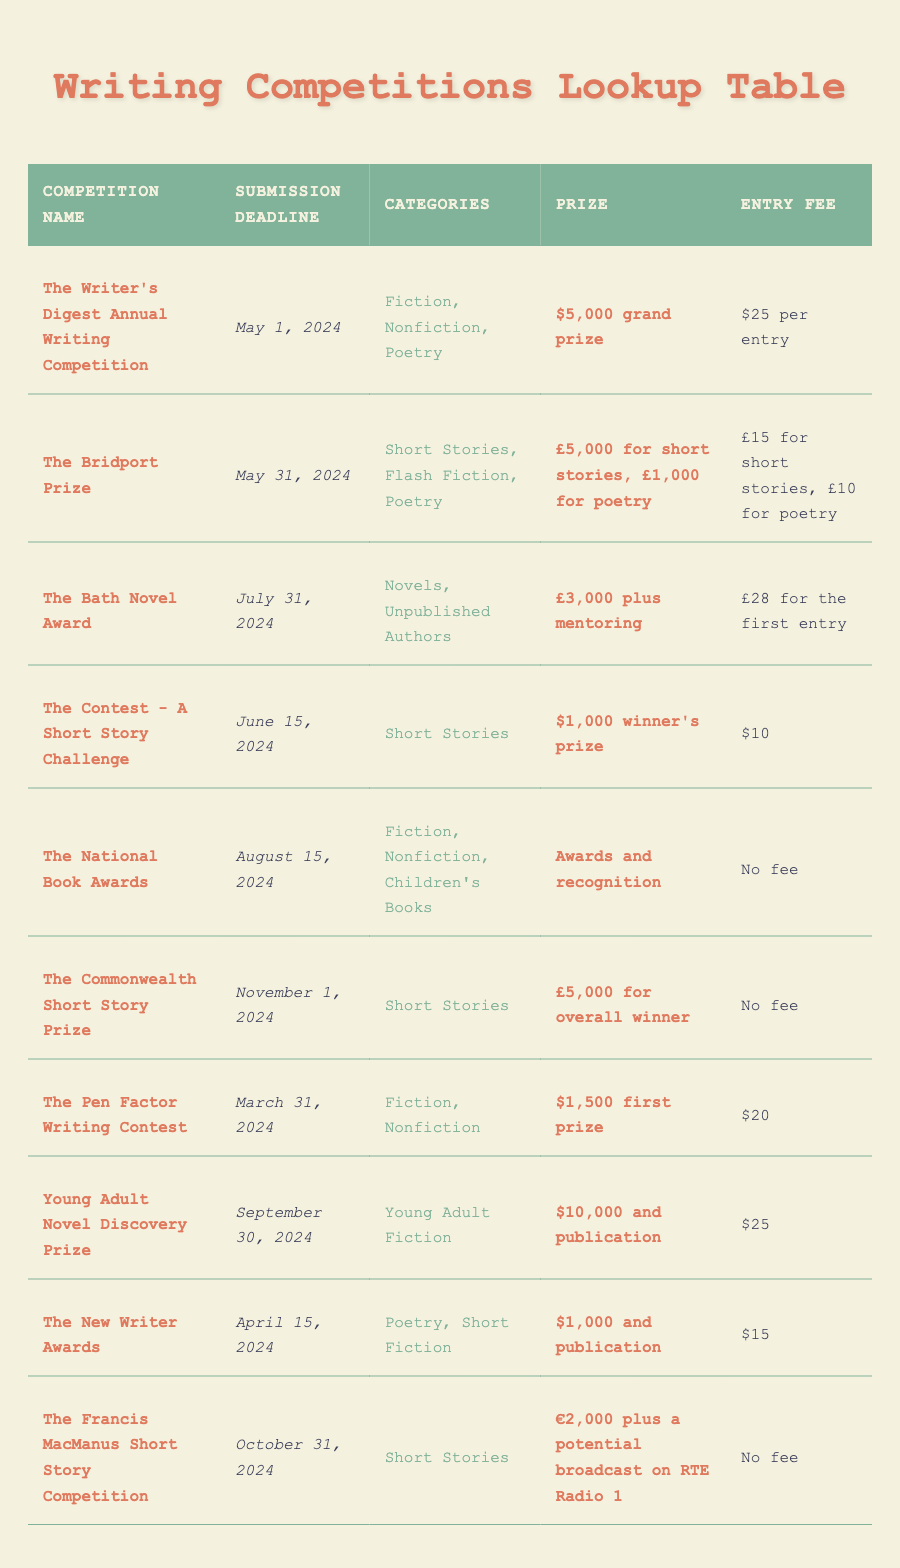What is the prize for The Bath Novel Award? The prize for The Bath Novel Award is specified in the table as £3,000 plus mentoring.
Answer: £3,000 plus mentoring What is the submission deadline for The Contest - A Short Story Challenge? The table lists the submission deadline for The Contest - A Short Story Challenge as June 15, 2024.
Answer: June 15, 2024 Which competitions have no entry fee? By reviewing the entry fee column in the table, we find that The National Book Awards, The Commonwealth Short Story Prize, and The Francis MacManus Short Story Competition have no entry fee.
Answer: The National Book Awards, The Commonwealth Short Story Prize, The Francis MacManus Short Story Competition How much total prize money can be won if a participant wins both The Writer's Digest Annual Writing Competition and The Pen Factor Writing Contest? The prize for The Writer's Digest Annual Writing Competition is $5,000, and for The Pen Factor Writing Contest, it is $1,500. Summing these gives $5,000 + $1,500 = $6,500.
Answer: $6,500 Is the submission deadline for The New Writer Awards before that of The Bridport Prize? The New Writer Awards has a submission deadline of April 15, 2024, while The Bridport Prize has a deadline of May 31, 2024. Since April 15 is before May 31, the answer is yes.
Answer: Yes Which competition has the earliest submission deadline? Looking through the submission deadlines, The Pen Factor Writing Contest has a deadline of March 31, 2024, which is the earliest compared to others.
Answer: The Pen Factor Writing Contest What is the average entry fee for competitions requiring payment? First, we identify the competitions with entry fees: The Writer's Digest Annual Writing Competition ($25), The Bridport Prize (average of £12.5), The Bath Novel Award (£28), The Contest ($10), The Pen Factor ($20), Young Adult Novel Discovery Prize ($25), The New Writer Awards ($15). Converting to USD for consistency (assuming £1 = $1.25), the fees convert to $31.25 (Bridport Prize average). Adding these up gives $25 + $31.25 + $35 + $10 + $20 + $25 + $15 = $156.25. There are 7 fees, so the average is $156.25 / 7 ≈ $22.32.
Answer: $22.32 What categories are allowed for The Commonwealth Short Story Prize? The table indicates that The Commonwealth Short Story Prize includes the category of Short Stories.
Answer: Short Stories Does The Francis MacManus Short Story Competition have an entry fee? The entry fee detail for The Francis MacManus Short Story Competition is listed in the table as "No fee." Therefore, the answer is no.
Answer: No 